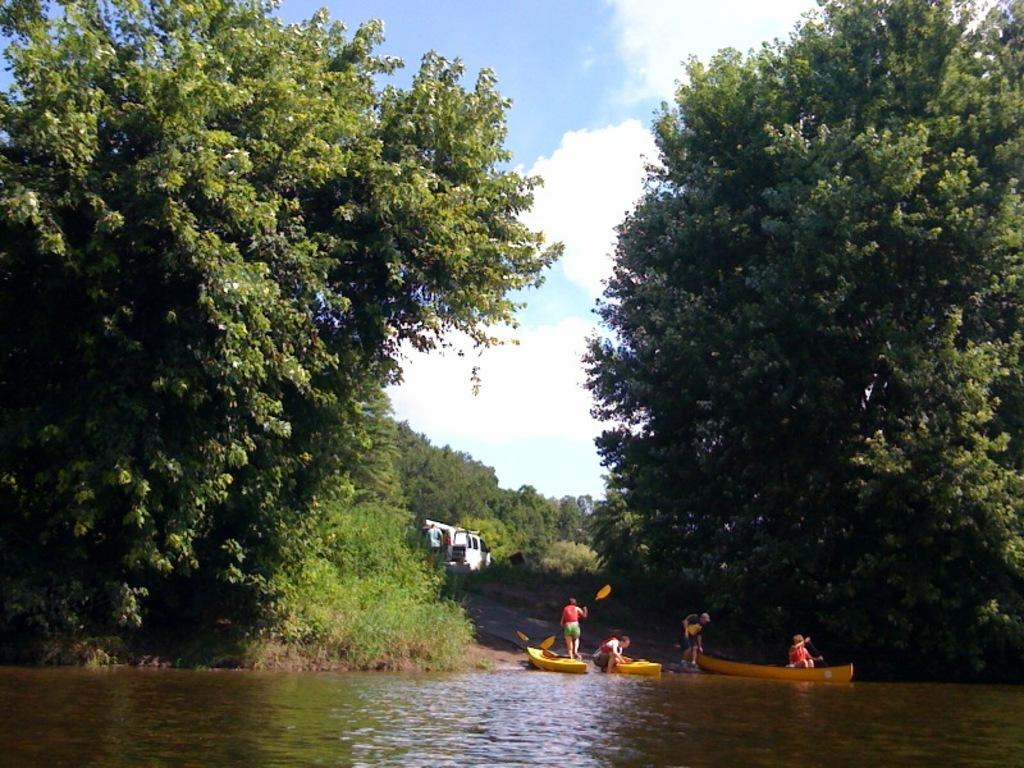What type of natural environment is depicted in the image? There are many trees in the image, suggesting a forest or wooded area. How many boats can be seen on the river in the image? There are three boats on the surface of the river in the image. Can you describe the people present in the image? People are present in the image, but their specific activities or characteristics are not mentioned in the provided facts. What is visible at the top of the image? The sky is visible at the top of the image. What can be observed about the sky in the image? There are clouds in the sky in the image. What type of fruit is hanging from the trees in the image? There is no mention of fruit in the provided facts, so we cannot determine if any fruit is hanging from the trees in the image. What is the condition of the river in the image? The provided facts do not mention the condition of the river, so we cannot determine its condition from the image. 